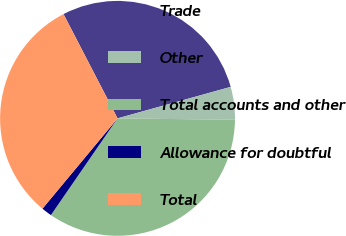Convert chart. <chart><loc_0><loc_0><loc_500><loc_500><pie_chart><fcel>Trade<fcel>Other<fcel>Total accounts and other<fcel>Allowance for doubtful<fcel>Total<nl><fcel>28.29%<fcel>4.51%<fcel>34.41%<fcel>1.44%<fcel>31.35%<nl></chart> 